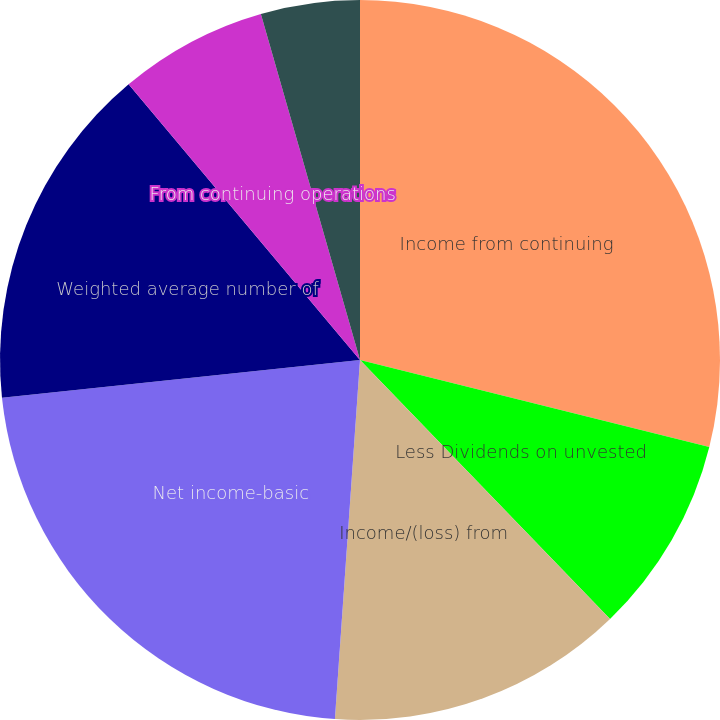Convert chart. <chart><loc_0><loc_0><loc_500><loc_500><pie_chart><fcel>Income from continuing<fcel>Less Dividends on unvested<fcel>Income/(loss) from<fcel>Net income-basic<fcel>Weighted average number of<fcel>From continuing operations<fcel>From discontinued operations<fcel>Total basic earnings per share<nl><fcel>28.89%<fcel>8.89%<fcel>13.33%<fcel>22.22%<fcel>15.56%<fcel>6.67%<fcel>0.0%<fcel>4.44%<nl></chart> 